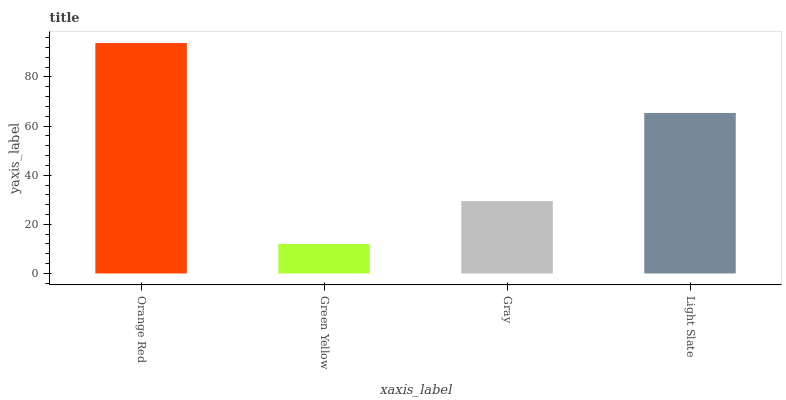Is Orange Red the maximum?
Answer yes or no. Yes. Is Gray the minimum?
Answer yes or no. No. Is Gray the maximum?
Answer yes or no. No. Is Gray greater than Green Yellow?
Answer yes or no. Yes. Is Green Yellow less than Gray?
Answer yes or no. Yes. Is Green Yellow greater than Gray?
Answer yes or no. No. Is Gray less than Green Yellow?
Answer yes or no. No. Is Light Slate the high median?
Answer yes or no. Yes. Is Gray the low median?
Answer yes or no. Yes. Is Green Yellow the high median?
Answer yes or no. No. Is Green Yellow the low median?
Answer yes or no. No. 